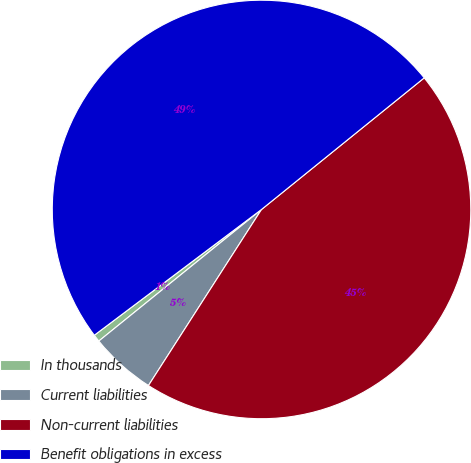Convert chart. <chart><loc_0><loc_0><loc_500><loc_500><pie_chart><fcel>In thousands<fcel>Current liabilities<fcel>Non-current liabilities<fcel>Benefit obligations in excess<nl><fcel>0.56%<fcel>5.09%<fcel>44.91%<fcel>49.44%<nl></chart> 